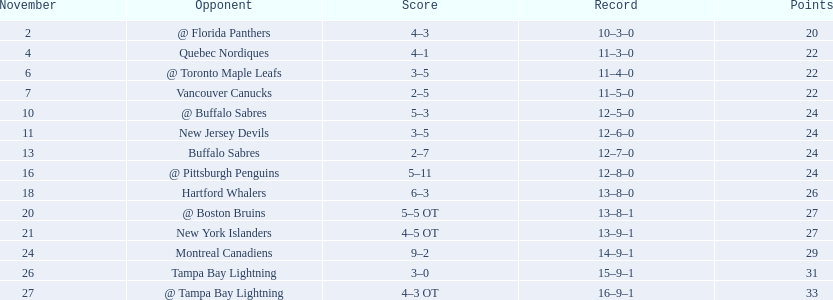Were the new jersey devils in last place according to the chart? No. 